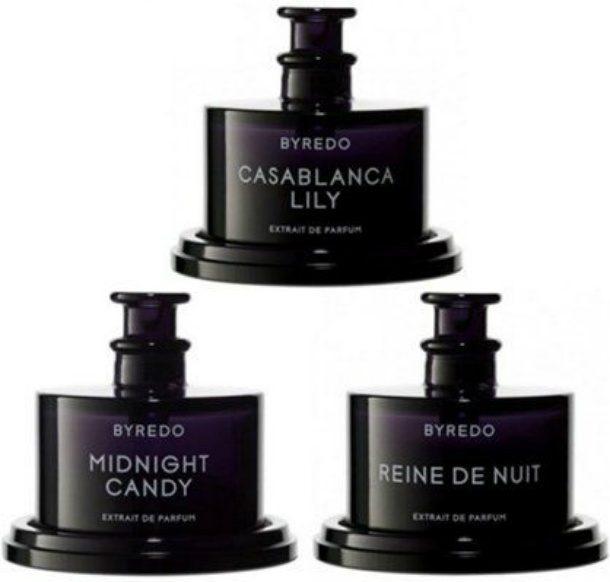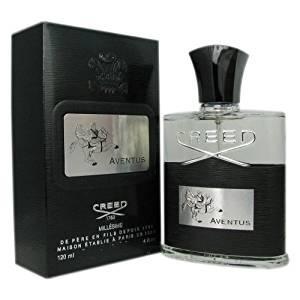The first image is the image on the left, the second image is the image on the right. Assess this claim about the two images: "There is one more container in the image on the left than there is in the image on the right.". Correct or not? Answer yes or no. Yes. The first image is the image on the left, the second image is the image on the right. Assess this claim about the two images: "An image shows a trio of fragance bottles of the same size and shape, displayed in a triangular formation.". Correct or not? Answer yes or no. Yes. 